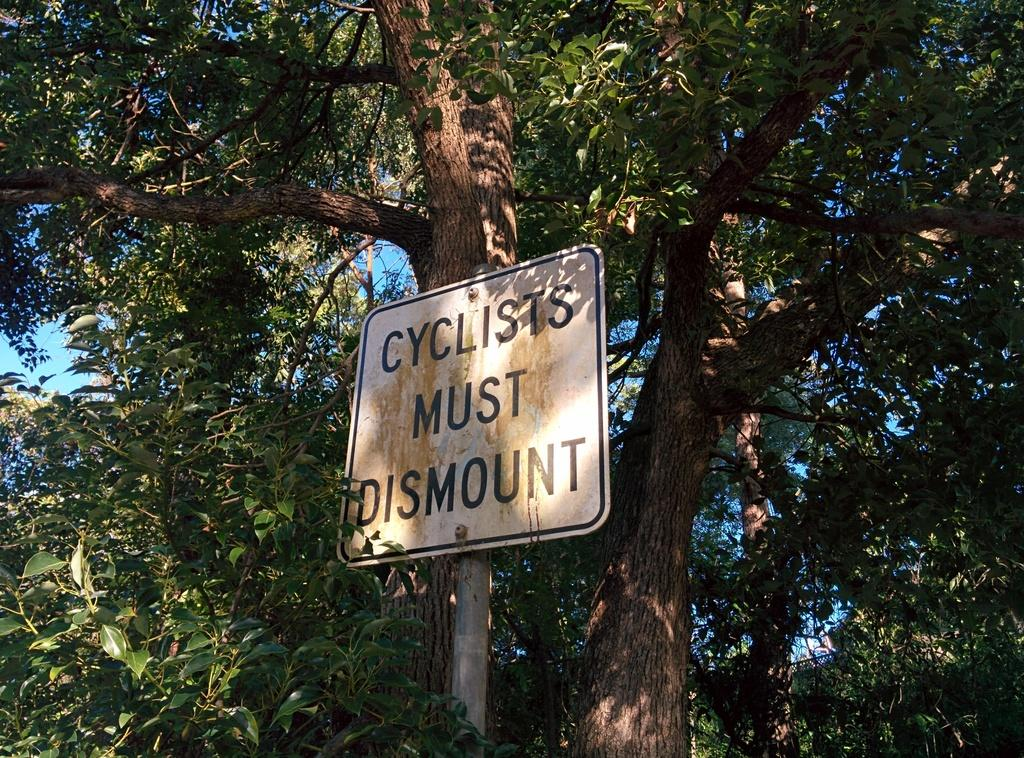What is the main object in the image? There is a name board in the image. How is the name board positioned in the image? The name board is attached to a pole. What can be seen in the background of the image? There are trees and the sky visible in the background of the image. Can you see a hose spraying water in harmony with the maid in the image? There is no hose or maid present in the image; it only features a name board and a pole. 